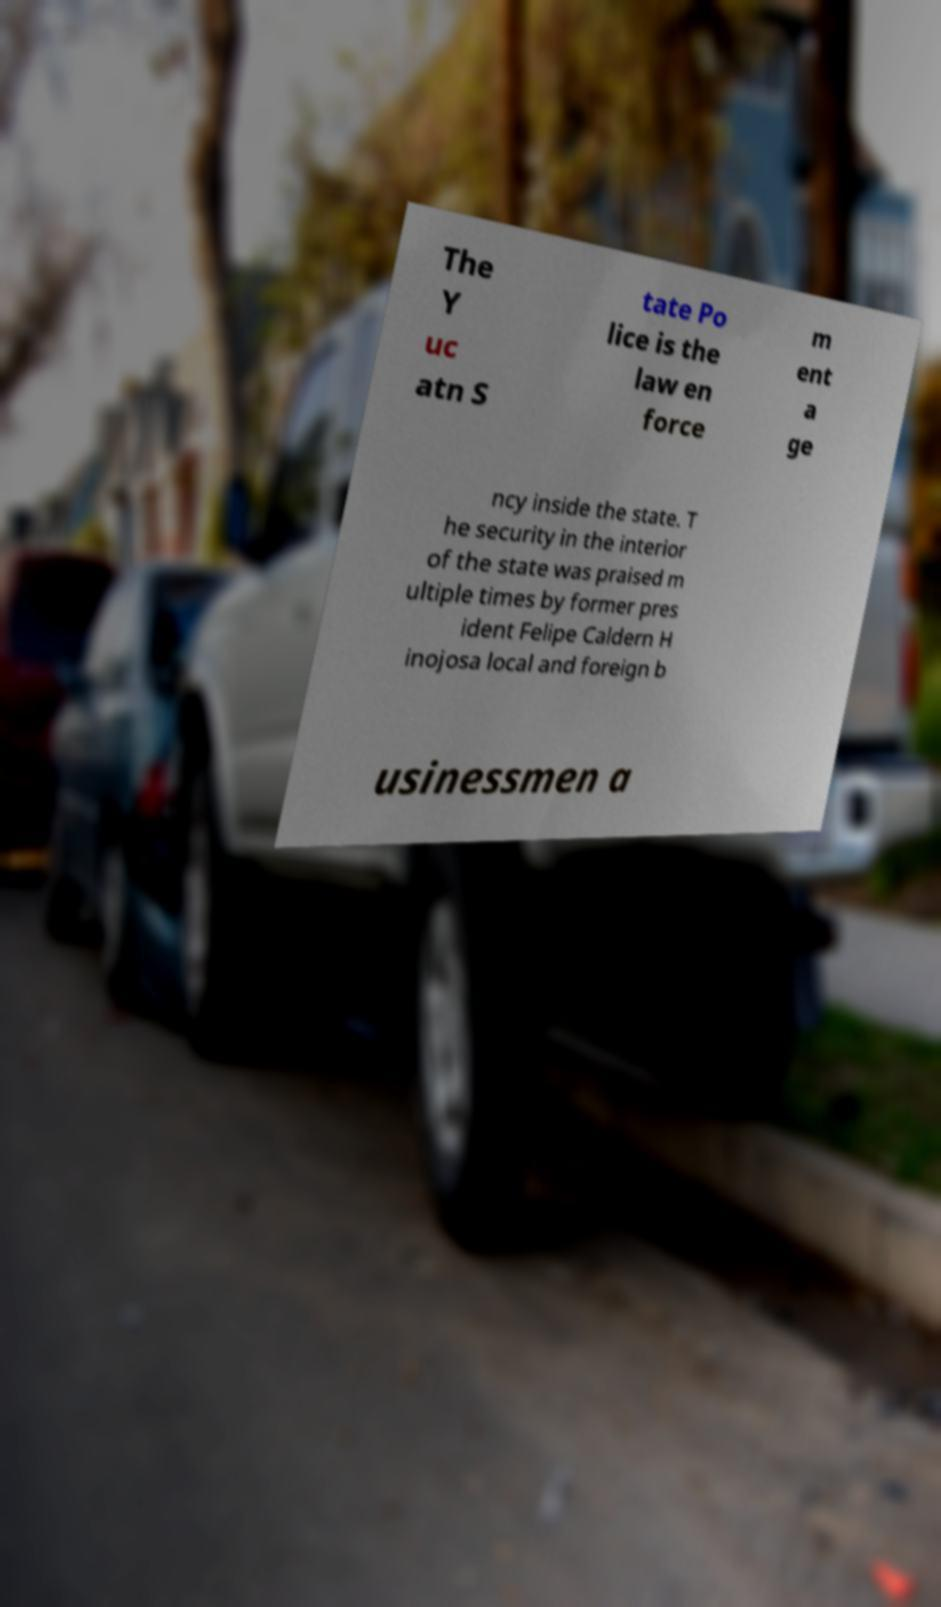There's text embedded in this image that I need extracted. Can you transcribe it verbatim? The Y uc atn S tate Po lice is the law en force m ent a ge ncy inside the state. T he security in the interior of the state was praised m ultiple times by former pres ident Felipe Caldern H inojosa local and foreign b usinessmen a 